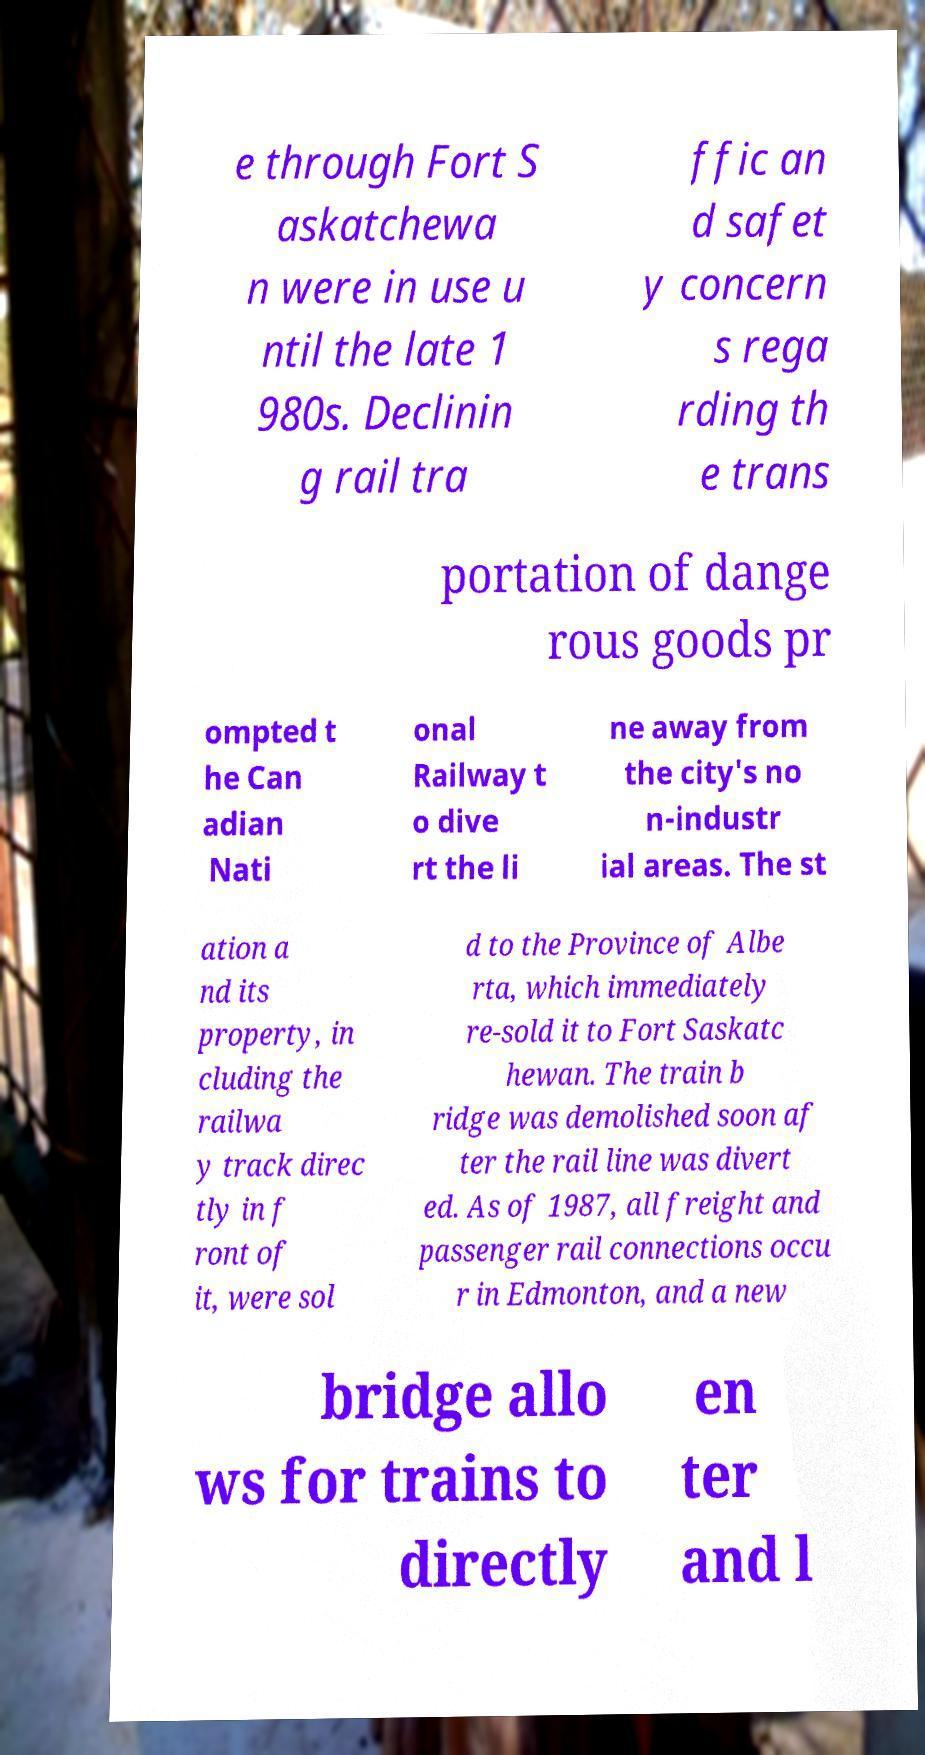Could you extract and type out the text from this image? e through Fort S askatchewa n were in use u ntil the late 1 980s. Declinin g rail tra ffic an d safet y concern s rega rding th e trans portation of dange rous goods pr ompted t he Can adian Nati onal Railway t o dive rt the li ne away from the city's no n-industr ial areas. The st ation a nd its property, in cluding the railwa y track direc tly in f ront of it, were sol d to the Province of Albe rta, which immediately re-sold it to Fort Saskatc hewan. The train b ridge was demolished soon af ter the rail line was divert ed. As of 1987, all freight and passenger rail connections occu r in Edmonton, and a new bridge allo ws for trains to directly en ter and l 